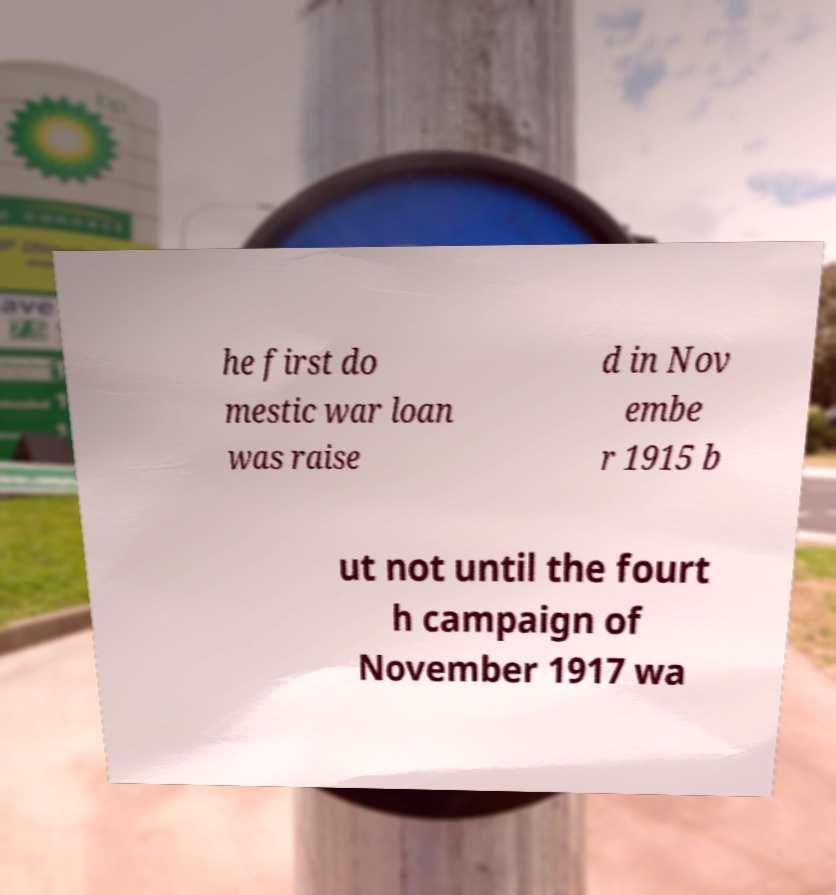Please identify and transcribe the text found in this image. he first do mestic war loan was raise d in Nov embe r 1915 b ut not until the fourt h campaign of November 1917 wa 